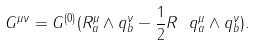Convert formula to latex. <formula><loc_0><loc_0><loc_500><loc_500>G ^ { \mu \nu } = G ^ { ( 0 ) } ( R _ { a } ^ { \mu } \wedge q _ { b } ^ { \nu } - \frac { 1 } { 2 } R \ q _ { a } ^ { \mu } \wedge q _ { b } ^ { \nu } ) .</formula> 